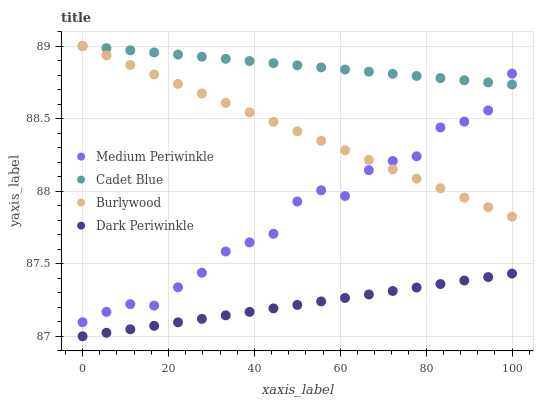Does Dark Periwinkle have the minimum area under the curve?
Answer yes or no. Yes. Does Cadet Blue have the maximum area under the curve?
Answer yes or no. Yes. Does Medium Periwinkle have the minimum area under the curve?
Answer yes or no. No. Does Medium Periwinkle have the maximum area under the curve?
Answer yes or no. No. Is Cadet Blue the smoothest?
Answer yes or no. Yes. Is Medium Periwinkle the roughest?
Answer yes or no. Yes. Is Medium Periwinkle the smoothest?
Answer yes or no. No. Is Cadet Blue the roughest?
Answer yes or no. No. Does Dark Periwinkle have the lowest value?
Answer yes or no. Yes. Does Medium Periwinkle have the lowest value?
Answer yes or no. No. Does Cadet Blue have the highest value?
Answer yes or no. Yes. Does Medium Periwinkle have the highest value?
Answer yes or no. No. Is Dark Periwinkle less than Medium Periwinkle?
Answer yes or no. Yes. Is Burlywood greater than Dark Periwinkle?
Answer yes or no. Yes. Does Cadet Blue intersect Medium Periwinkle?
Answer yes or no. Yes. Is Cadet Blue less than Medium Periwinkle?
Answer yes or no. No. Is Cadet Blue greater than Medium Periwinkle?
Answer yes or no. No. Does Dark Periwinkle intersect Medium Periwinkle?
Answer yes or no. No. 